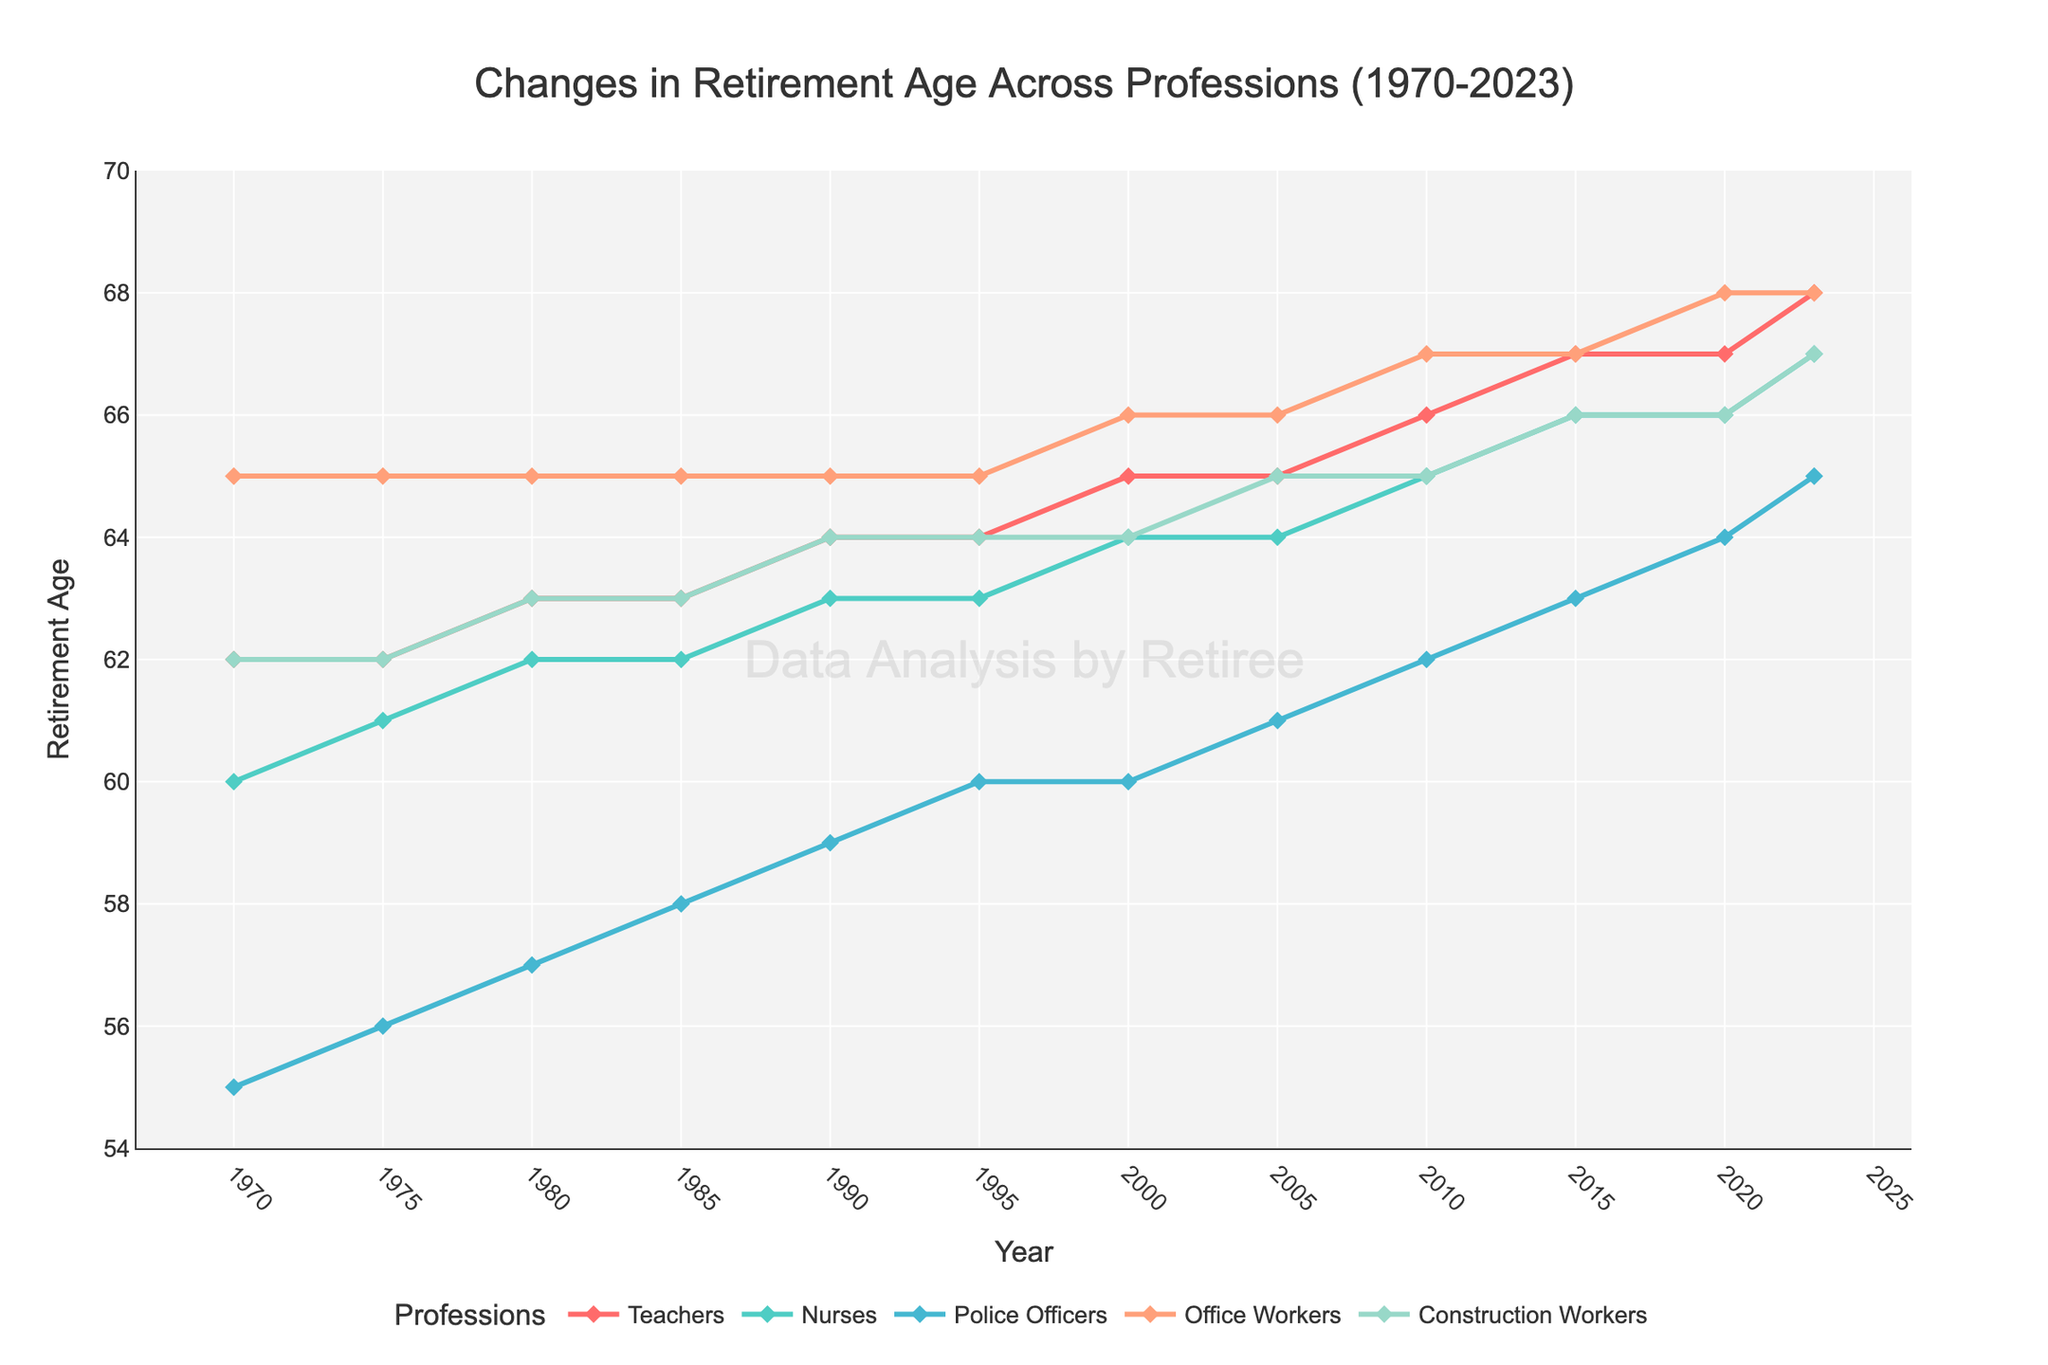What is the retirement age for Police Officers in 1985? Locate the point at the intersection of the "Police Officers" line and the year 1985 on the x-axis. The y-coordinate of this point shows the retirement age.
Answer: 58 Which profession had the highest retirement age in 2020? Compare the heights of the points for all professions at the year 2020. The highest point corresponds to the highest retirement age.
Answer: Office Workers What is the difference in retirement age between Teachers and Construction Workers in 2023? Find the y-coordinates of the lines for Teachers and Construction Workers at the year 2023. The difference is calculated as 68 - 67.
Answer: 1 year Which two professions had the same retirement age in 1970? Look for professions whose lines intersect at the year 1970. Check their y-coordinates to see if they match. Teachers and Construction Workers both have the retirement age of 62 in 1970.
Answer: Teachers and Construction Workers How did the retirement age for Nurses change from 2010 to 2023? Locate the points for Nurses at both 2010 and 2023 on the x-axis. The retirement age for Nurses increases from 65 in 2010 to 67 in 2023.
Answer: Increased by 2 years Which profession experienced the most significant increase in retirement age from 1970 to 2023? Calculate the increase for each profession by subtracting the 1970 retirement age from the 2023 retirement age. Police Officers went from 55 in 1970 to 65 in 2023, an increase of 10 years. Compare it with other professions.
Answer: Police Officers What is the average retirement age for Office Workers in 2000, 2010, and 2020? Identify the y-coordinates for Office Workers in 2000, 2010, and 2020, which are 66, 67, and 68 respectively. Sum these values and divide by 3 to find the average: (66+67+68)/3.
Answer: 67 years Which profession had the most stable retirement age between 1970 and 2023? Check the lines for each profession to see which one shows the least fluctuation or change over the years. Office Workers’ retirement age changes minimally from 65 in 1970 to 68 in 2023.
Answer: Office Workers How much did the retirement age for Teachers increase from 1980 to 2015? Identify the y-coordinates for Teachers in the years 1980 and 2015, which are 63 and 67 respectively. The increase is calculated as 67 - 63.
Answer: 4 years 